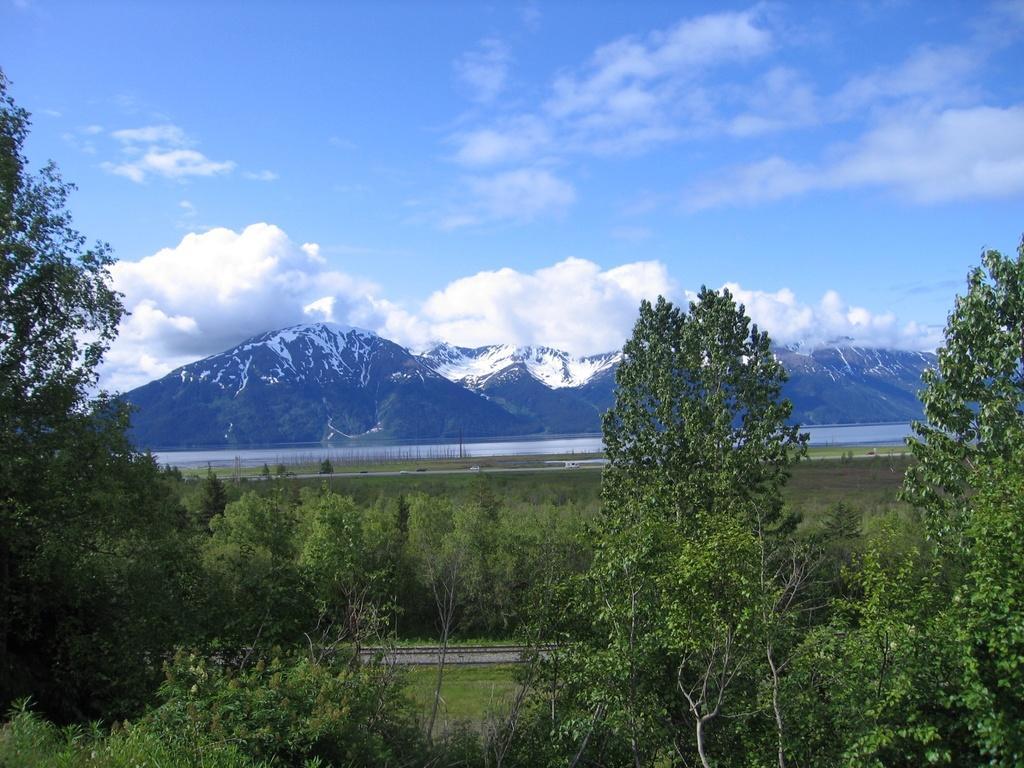In one or two sentences, can you explain what this image depicts? In the center of the image there is a railway track. There are trees. There is water. There is snow on the mountains. In the background of the image there is sky. 